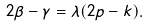Convert formula to latex. <formula><loc_0><loc_0><loc_500><loc_500>2 \beta - \gamma = \lambda ( 2 p - k ) .</formula> 